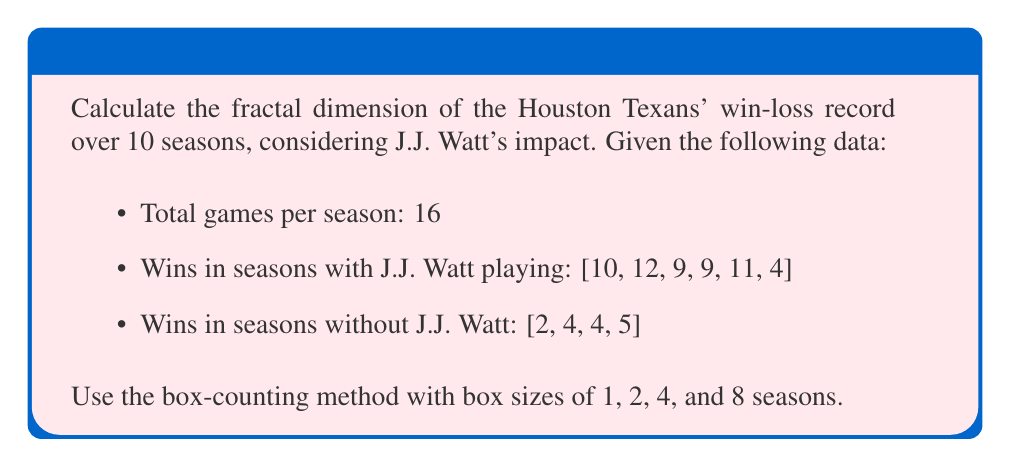Give your solution to this math problem. To calculate the fractal dimension using the box-counting method, we'll follow these steps:

1. Arrange the data:
   [10, 12, 9, 9, 11, 4, 2, 4, 4, 5]

2. Count the number of boxes N(r) needed to cover the data for each box size r:
   r = 1: N(1) = 10 (each season is a separate box)
   r = 2: N(2) = 5 (pairs of seasons)
   r = 4: N(4) = 3 (groups of four seasons)
   r = 8: N(8) = 2 (two groups of eight seasons)

3. Calculate log(N(r)) and log(1/r) for each r:
   r = 1: log(N(1)) = log(10) ≈ 2.303, log(1/1) = 0
   r = 2: log(N(2)) = log(5) ≈ 1.609, log(1/2) = log(0.5) ≈ -0.693
   r = 4: log(N(4)) = log(3) ≈ 1.099, log(1/4) = log(0.25) ≈ -1.386
   r = 8: log(N(8)) = log(2) ≈ 0.693, log(1/8) = log(0.125) ≈ -2.079

4. Plot log(N(r)) vs. log(1/r) and find the slope of the best-fit line:

   [asy]
   import graph;
   size(200,200);
   
   real[] x = {0, -0.693, -1.386, -2.079};
   real[] y = {2.303, 1.609, 1.099, 0.693};
   
   for(int i=0; i < 4; ++i) {
     dot((x[i], y[i]));
   }
   
   draw(graph(x,y));
   
   xaxis("log(1/r)", arrow=Arrow);
   yaxis("log(N(r))", arrow=Arrow);
   [/asy]

5. The fractal dimension D is the slope of this line. We can estimate it using the formula:

   $$D = \frac{\Delta \log(N(r))}{\Delta \log(1/r)} \approx \frac{2.303 - 0.693}{0 - (-2.079)} \approx 0.774$$

The fractal dimension of 0.774 indicates that the win-loss record has some self-similarity but is not as complex as a fully developed fractal (which would have a non-integer dimension between 1 and 2).
Answer: 0.774 